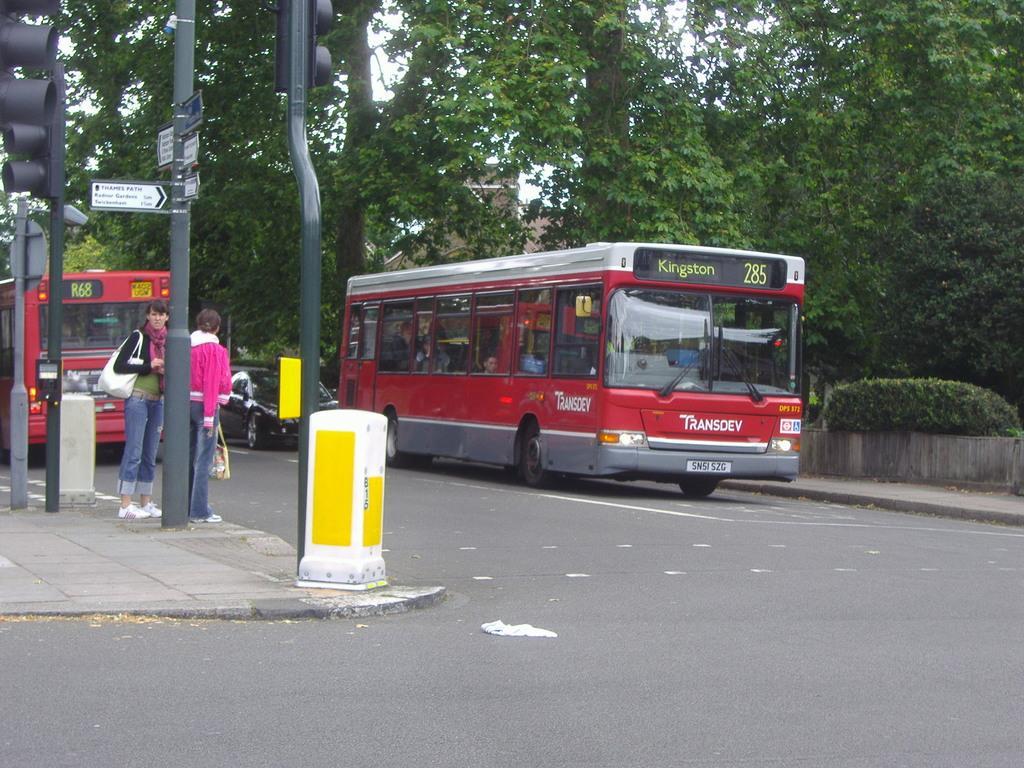How would you summarize this image in a sentence or two? In this image there are two red color buses on the road, two persons standing, plants, direction boards and signal lights attached to the poles, trees, building, sky. 